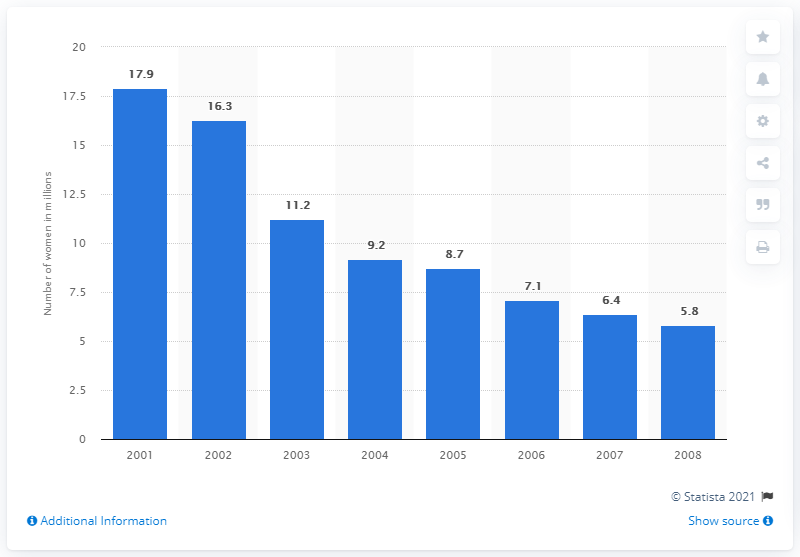Highlight a few significant elements in this photo. In 2001, an estimated 17.9% of women in the United States reported using hormone replacement therapy drugs. 